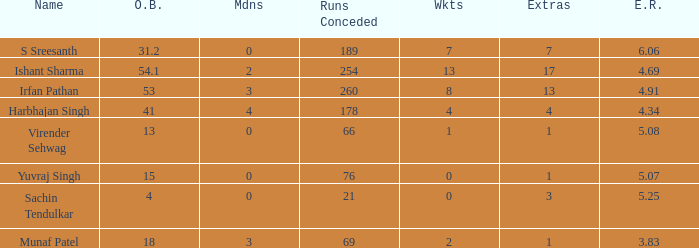What do you call the situation when 3 S Sreesanth. Could you parse the entire table as a dict? {'header': ['Name', 'O.B.', 'Mdns', 'Runs Conceded', 'Wkts', 'Extras', 'E.R.'], 'rows': [['S Sreesanth', '31.2', '0', '189', '7', '7', '6.06'], ['Ishant Sharma', '54.1', '2', '254', '13', '17', '4.69'], ['Irfan Pathan', '53', '3', '260', '8', '13', '4.91'], ['Harbhajan Singh', '41', '4', '178', '4', '4', '4.34'], ['Virender Sehwag', '13', '0', '66', '1', '1', '5.08'], ['Yuvraj Singh', '15', '0', '76', '0', '1', '5.07'], ['Sachin Tendulkar', '4', '0', '21', '0', '3', '5.25'], ['Munaf Patel', '18', '3', '69', '2', '1', '3.83']]} 